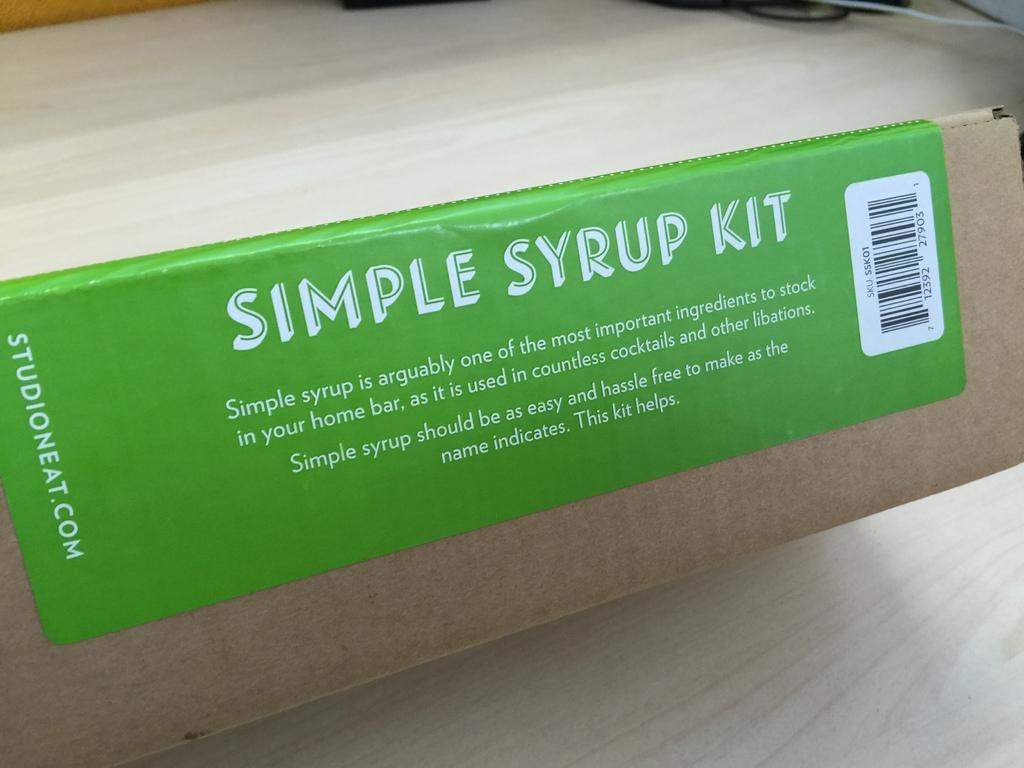What type of kit is this?
Provide a succinct answer. Simple syrup. 